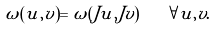<formula> <loc_0><loc_0><loc_500><loc_500>\omega ( u , v ) = \omega ( J u , J v ) \quad \forall u , v .</formula> 